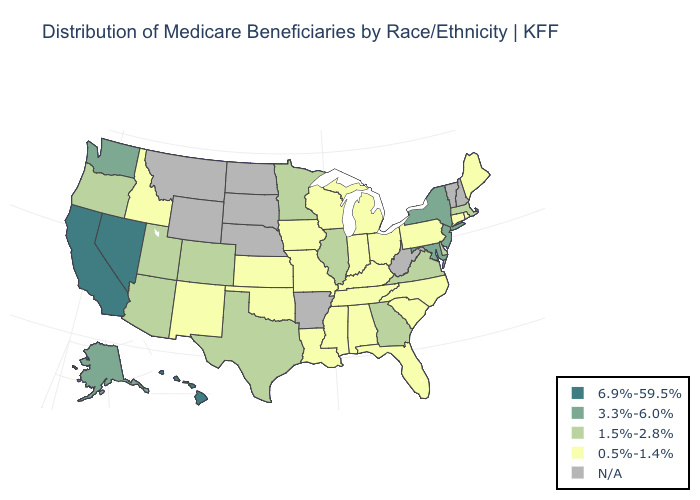Name the states that have a value in the range N/A?
Short answer required. Arkansas, Montana, Nebraska, New Hampshire, North Dakota, South Dakota, Vermont, West Virginia, Wyoming. What is the value of Rhode Island?
Quick response, please. 0.5%-1.4%. What is the highest value in the Northeast ?
Be succinct. 3.3%-6.0%. What is the highest value in the Northeast ?
Write a very short answer. 3.3%-6.0%. Among the states that border New Hampshire , does Maine have the highest value?
Be succinct. No. What is the lowest value in the USA?
Be succinct. 0.5%-1.4%. Name the states that have a value in the range N/A?
Write a very short answer. Arkansas, Montana, Nebraska, New Hampshire, North Dakota, South Dakota, Vermont, West Virginia, Wyoming. Name the states that have a value in the range 1.5%-2.8%?
Short answer required. Arizona, Colorado, Delaware, Georgia, Illinois, Massachusetts, Minnesota, Oregon, Texas, Utah, Virginia. What is the highest value in states that border West Virginia?
Short answer required. 3.3%-6.0%. Which states have the lowest value in the Northeast?
Answer briefly. Connecticut, Maine, Pennsylvania, Rhode Island. Name the states that have a value in the range 3.3%-6.0%?
Answer briefly. Alaska, Maryland, New Jersey, New York, Washington. Name the states that have a value in the range N/A?
Quick response, please. Arkansas, Montana, Nebraska, New Hampshire, North Dakota, South Dakota, Vermont, West Virginia, Wyoming. Among the states that border Nevada , which have the lowest value?
Keep it brief. Idaho. What is the lowest value in the Northeast?
Short answer required. 0.5%-1.4%. 